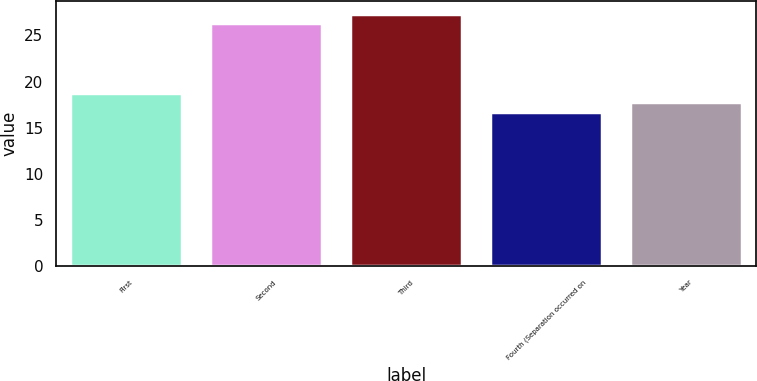Convert chart to OTSL. <chart><loc_0><loc_0><loc_500><loc_500><bar_chart><fcel>First<fcel>Second<fcel>Third<fcel>Fourth (Separation occurred on<fcel>Year<nl><fcel>18.81<fcel>26.34<fcel>27.37<fcel>16.75<fcel>17.78<nl></chart> 